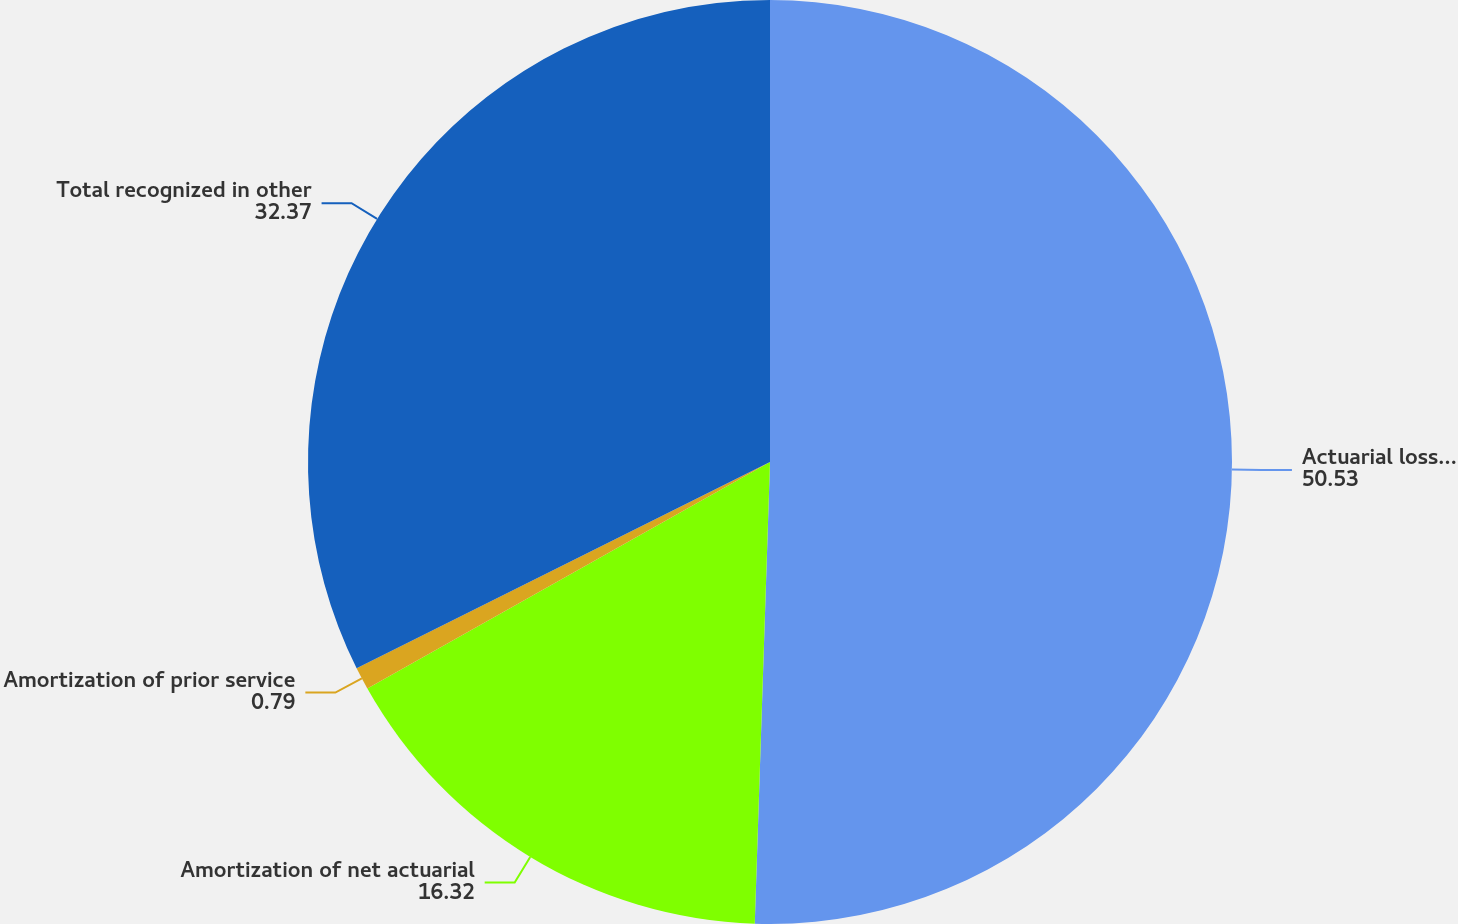<chart> <loc_0><loc_0><loc_500><loc_500><pie_chart><fcel>Actuarial loss arising during<fcel>Amortization of net actuarial<fcel>Amortization of prior service<fcel>Total recognized in other<nl><fcel>50.53%<fcel>16.32%<fcel>0.79%<fcel>32.37%<nl></chart> 